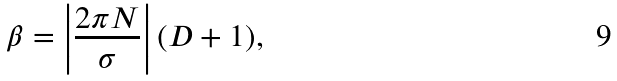<formula> <loc_0><loc_0><loc_500><loc_500>\beta = \left | \frac { 2 \pi N } { \sigma } \right | ( D + 1 ) ,</formula> 